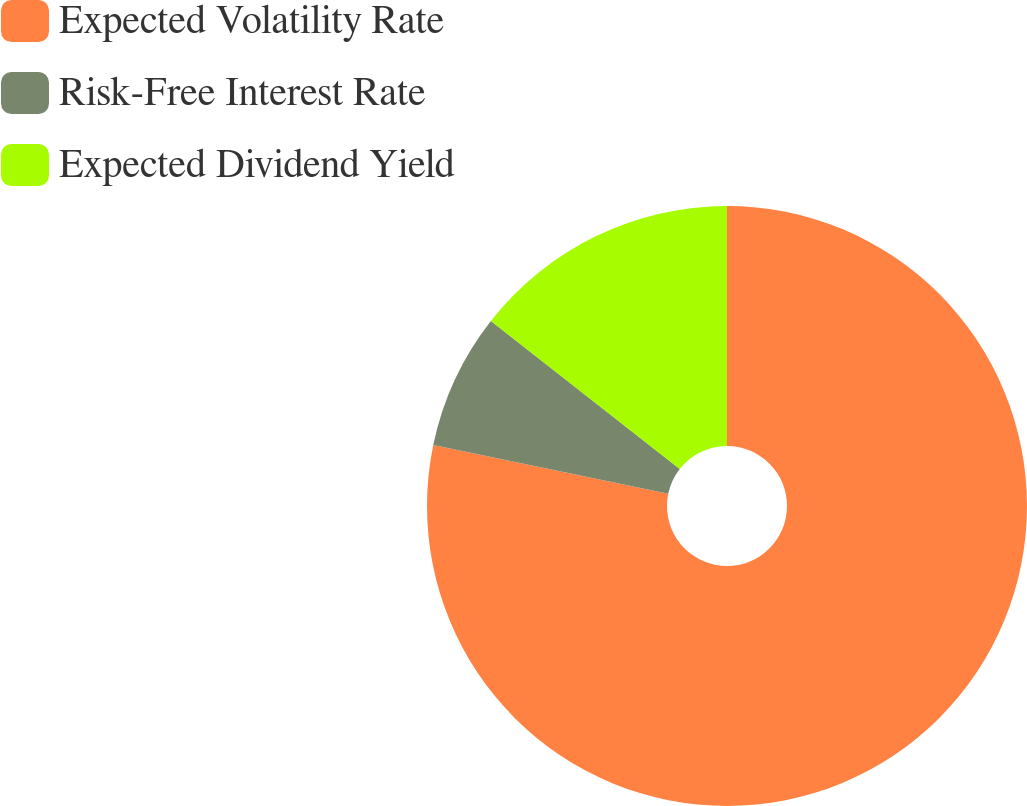<chart> <loc_0><loc_0><loc_500><loc_500><pie_chart><fcel>Expected Volatility Rate<fcel>Risk-Free Interest Rate<fcel>Expected Dividend Yield<nl><fcel>78.26%<fcel>7.32%<fcel>14.42%<nl></chart> 